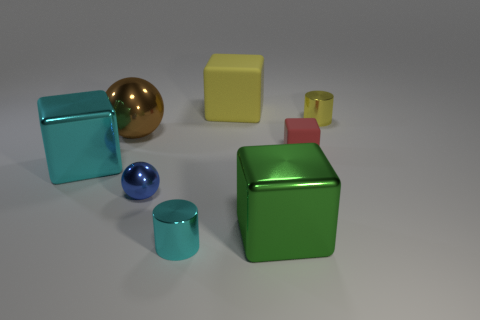Add 1 small purple shiny spheres. How many objects exist? 9 Subtract all spheres. How many objects are left? 6 Add 8 balls. How many balls exist? 10 Subtract 1 brown spheres. How many objects are left? 7 Subtract all big red things. Subtract all brown shiny balls. How many objects are left? 7 Add 4 yellow things. How many yellow things are left? 6 